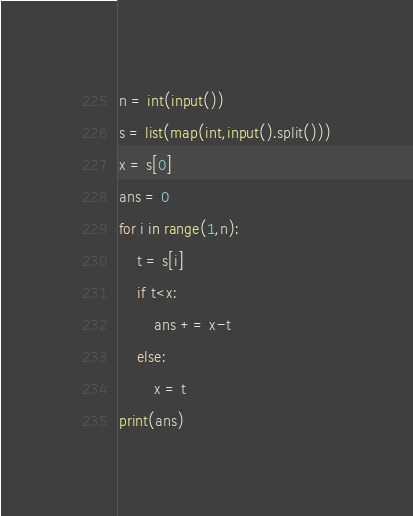Convert code to text. <code><loc_0><loc_0><loc_500><loc_500><_Python_>n = int(input())
s = list(map(int,input().split()))
x = s[0]
ans = 0
for i in range(1,n):
    t = s[i]
    if t<x:
        ans += x-t
    else:
        x = t
print(ans)</code> 